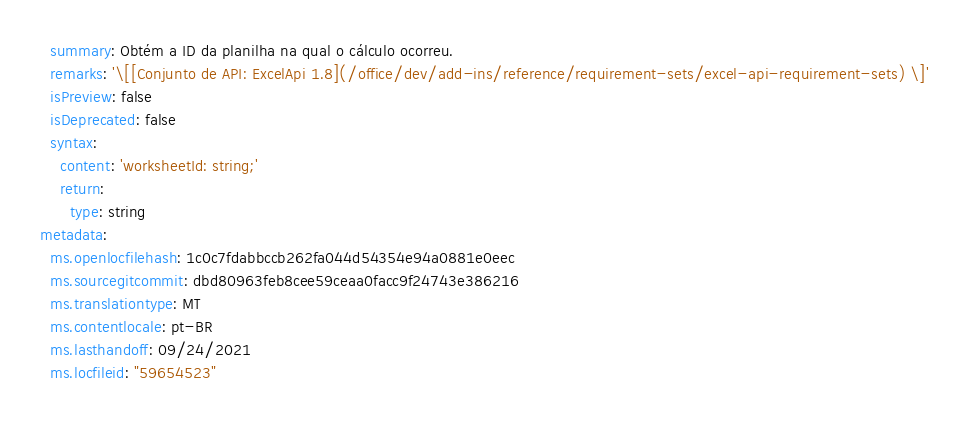<code> <loc_0><loc_0><loc_500><loc_500><_YAML_>  summary: Obtém a ID da planilha na qual o cálculo ocorreu.
  remarks: '\[[Conjunto de API: ExcelApi 1.8](/office/dev/add-ins/reference/requirement-sets/excel-api-requirement-sets) \]'
  isPreview: false
  isDeprecated: false
  syntax:
    content: 'worksheetId: string;'
    return:
      type: string
metadata:
  ms.openlocfilehash: 1c0c7fdabbccb262fa044d54354e94a0881e0eec
  ms.sourcegitcommit: dbd80963feb8cee59ceaa0facc9f24743e386216
  ms.translationtype: MT
  ms.contentlocale: pt-BR
  ms.lasthandoff: 09/24/2021
  ms.locfileid: "59654523"
</code> 